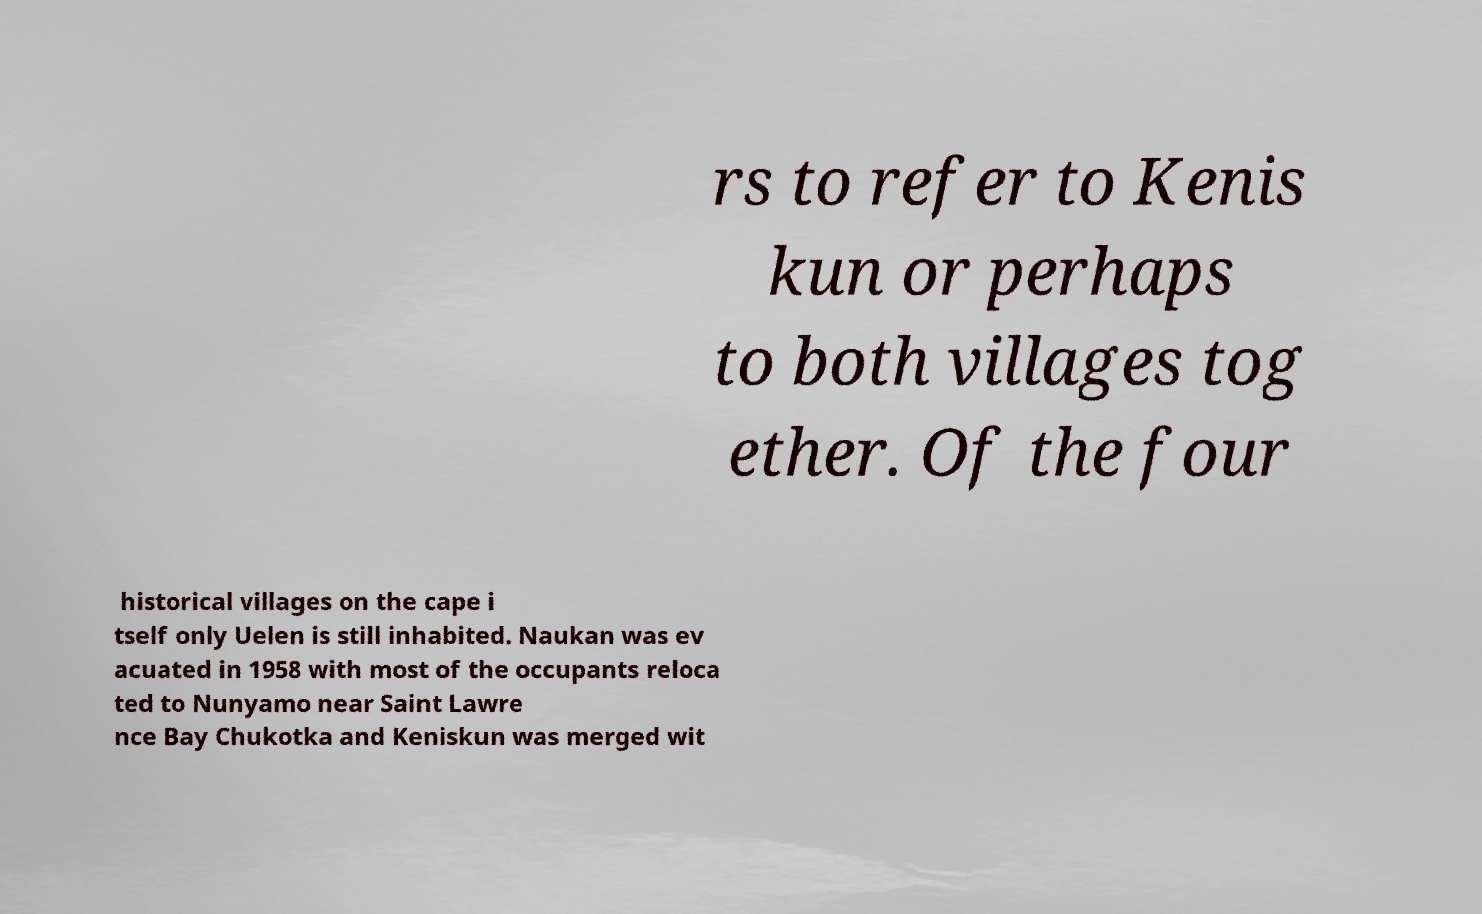Can you accurately transcribe the text from the provided image for me? rs to refer to Kenis kun or perhaps to both villages tog ether. Of the four historical villages on the cape i tself only Uelen is still inhabited. Naukan was ev acuated in 1958 with most of the occupants reloca ted to Nunyamo near Saint Lawre nce Bay Chukotka and Keniskun was merged wit 